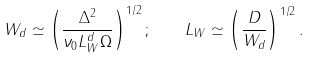Convert formula to latex. <formula><loc_0><loc_0><loc_500><loc_500>W _ { d } \simeq \left ( \frac { \Delta ^ { 2 } } { \nu _ { 0 } L _ { W } ^ { d } \Omega } \right ) ^ { 1 / 2 } ; \quad L _ { W } \simeq \left ( \frac { D } { W _ { d } } \right ) ^ { 1 / 2 } .</formula> 